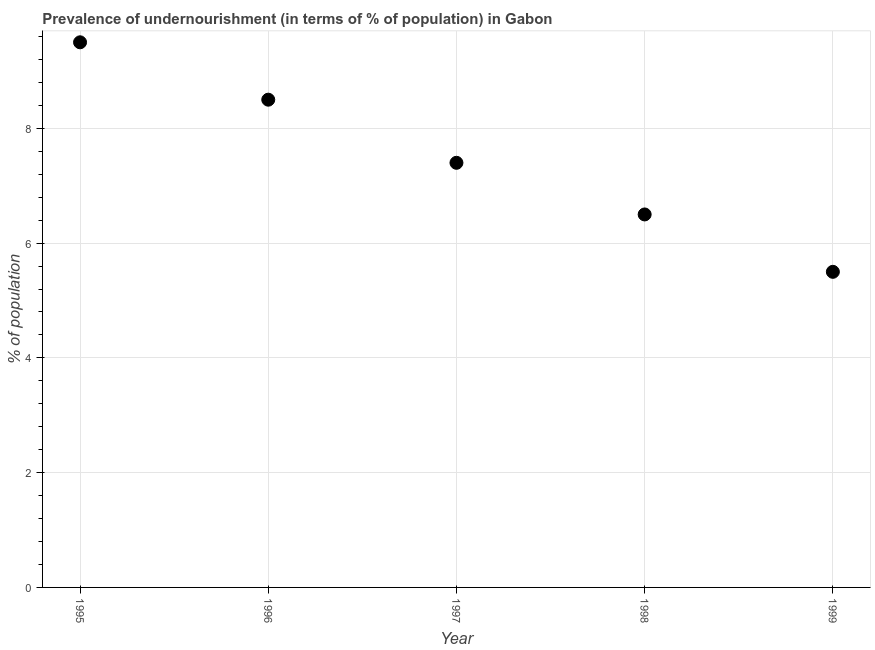Across all years, what is the minimum percentage of undernourished population?
Your answer should be compact. 5.5. In which year was the percentage of undernourished population maximum?
Your response must be concise. 1995. What is the sum of the percentage of undernourished population?
Provide a short and direct response. 37.4. What is the difference between the percentage of undernourished population in 1996 and 1997?
Make the answer very short. 1.1. What is the average percentage of undernourished population per year?
Your answer should be compact. 7.48. What is the ratio of the percentage of undernourished population in 1995 to that in 1999?
Give a very brief answer. 1.73. Is the difference between the percentage of undernourished population in 1998 and 1999 greater than the difference between any two years?
Provide a succinct answer. No. How many dotlines are there?
Make the answer very short. 1. How many years are there in the graph?
Your answer should be very brief. 5. What is the difference between two consecutive major ticks on the Y-axis?
Make the answer very short. 2. Are the values on the major ticks of Y-axis written in scientific E-notation?
Your answer should be compact. No. Does the graph contain any zero values?
Offer a terse response. No. Does the graph contain grids?
Your answer should be very brief. Yes. What is the title of the graph?
Offer a terse response. Prevalence of undernourishment (in terms of % of population) in Gabon. What is the label or title of the X-axis?
Your answer should be compact. Year. What is the label or title of the Y-axis?
Make the answer very short. % of population. What is the % of population in 1996?
Offer a very short reply. 8.5. What is the % of population in 1997?
Offer a very short reply. 7.4. What is the % of population in 1998?
Provide a short and direct response. 6.5. What is the % of population in 1999?
Provide a short and direct response. 5.5. What is the difference between the % of population in 1995 and 1996?
Make the answer very short. 1. What is the difference between the % of population in 1995 and 1997?
Provide a short and direct response. 2.1. What is the difference between the % of population in 1995 and 1999?
Keep it short and to the point. 4. What is the difference between the % of population in 1996 and 1997?
Provide a short and direct response. 1.1. What is the difference between the % of population in 1996 and 1999?
Your response must be concise. 3. What is the difference between the % of population in 1997 and 1999?
Make the answer very short. 1.9. What is the ratio of the % of population in 1995 to that in 1996?
Your answer should be very brief. 1.12. What is the ratio of the % of population in 1995 to that in 1997?
Give a very brief answer. 1.28. What is the ratio of the % of population in 1995 to that in 1998?
Give a very brief answer. 1.46. What is the ratio of the % of population in 1995 to that in 1999?
Your answer should be compact. 1.73. What is the ratio of the % of population in 1996 to that in 1997?
Provide a short and direct response. 1.15. What is the ratio of the % of population in 1996 to that in 1998?
Make the answer very short. 1.31. What is the ratio of the % of population in 1996 to that in 1999?
Your answer should be very brief. 1.54. What is the ratio of the % of population in 1997 to that in 1998?
Provide a succinct answer. 1.14. What is the ratio of the % of population in 1997 to that in 1999?
Your answer should be compact. 1.34. What is the ratio of the % of population in 1998 to that in 1999?
Give a very brief answer. 1.18. 